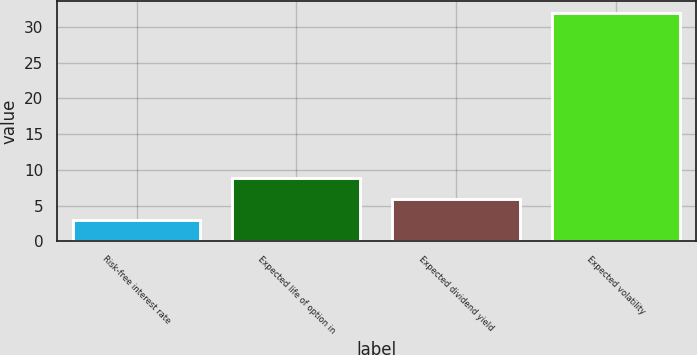<chart> <loc_0><loc_0><loc_500><loc_500><bar_chart><fcel>Risk-free interest rate<fcel>Expected life of option in<fcel>Expected dividend yield<fcel>Expected volatility<nl><fcel>3<fcel>8.8<fcel>5.9<fcel>32<nl></chart> 